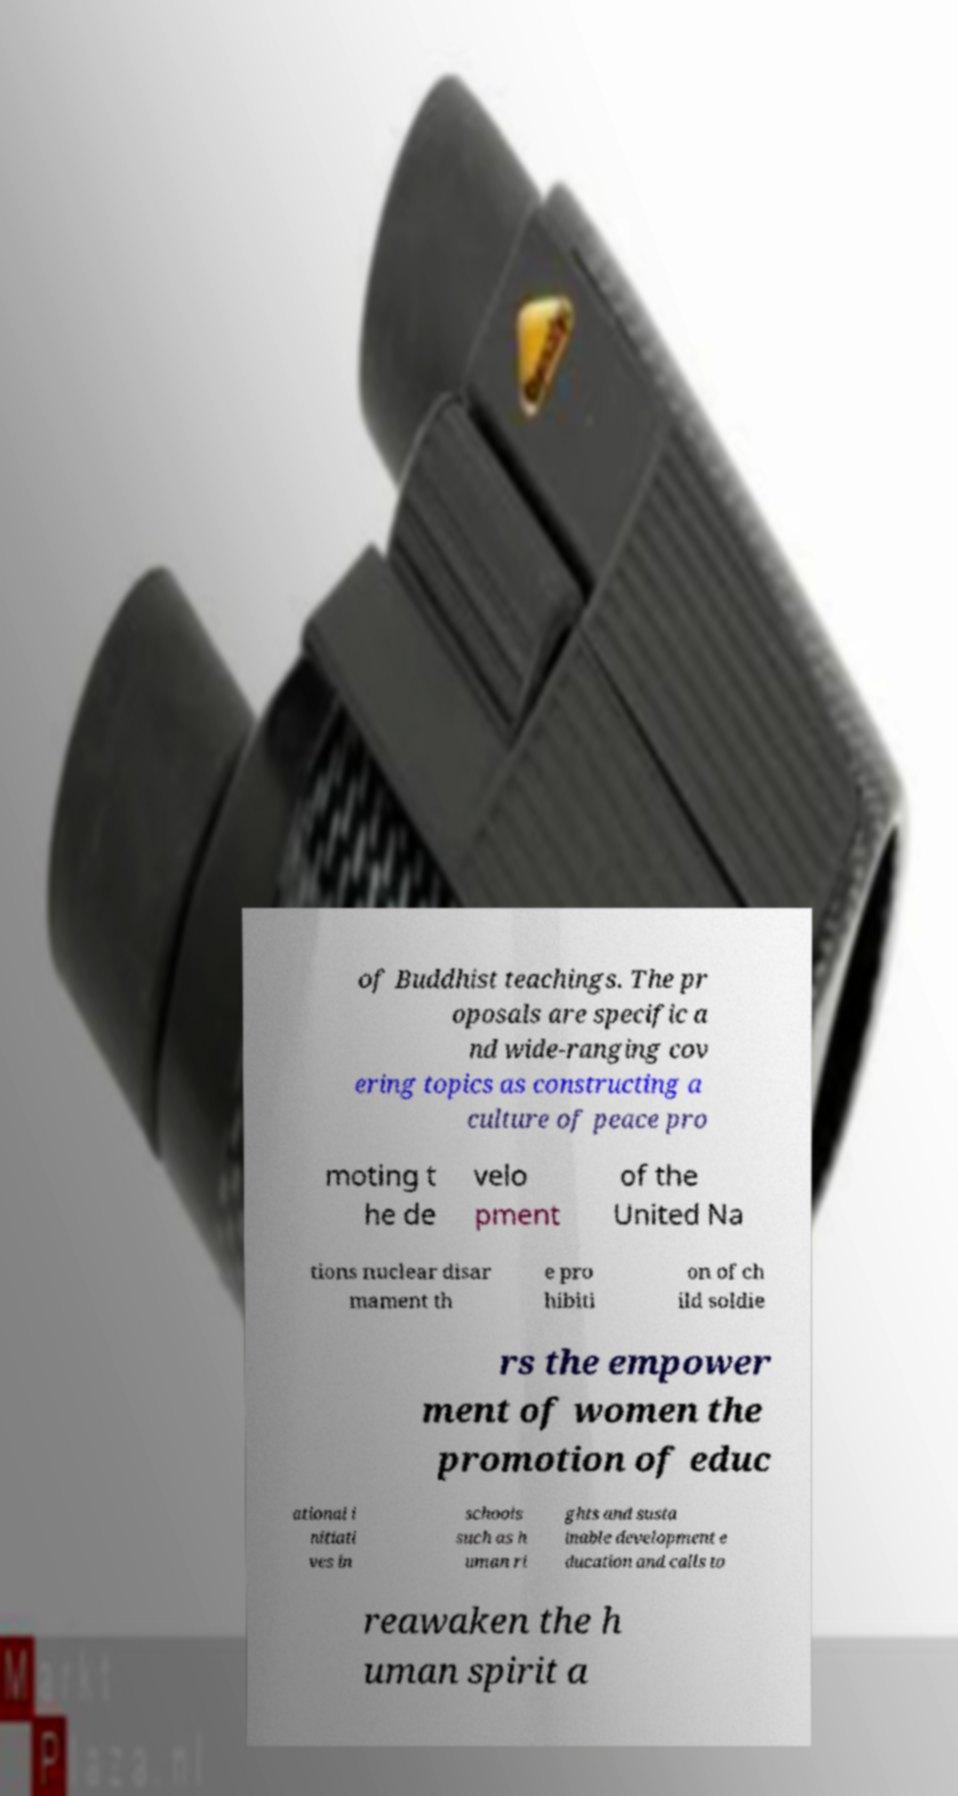There's text embedded in this image that I need extracted. Can you transcribe it verbatim? of Buddhist teachings. The pr oposals are specific a nd wide-ranging cov ering topics as constructing a culture of peace pro moting t he de velo pment of the United Na tions nuclear disar mament th e pro hibiti on of ch ild soldie rs the empower ment of women the promotion of educ ational i nitiati ves in schools such as h uman ri ghts and susta inable development e ducation and calls to reawaken the h uman spirit a 